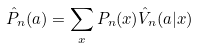Convert formula to latex. <formula><loc_0><loc_0><loc_500><loc_500>\hat { P } _ { n } ( a ) = \sum _ { x } P _ { n } ( x ) \hat { V } _ { n } ( a | x )</formula> 